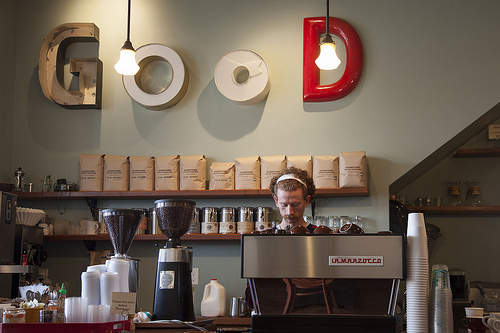<image>
Is the milk behind the man? Yes. From this viewpoint, the milk is positioned behind the man, with the man partially or fully occluding the milk. 